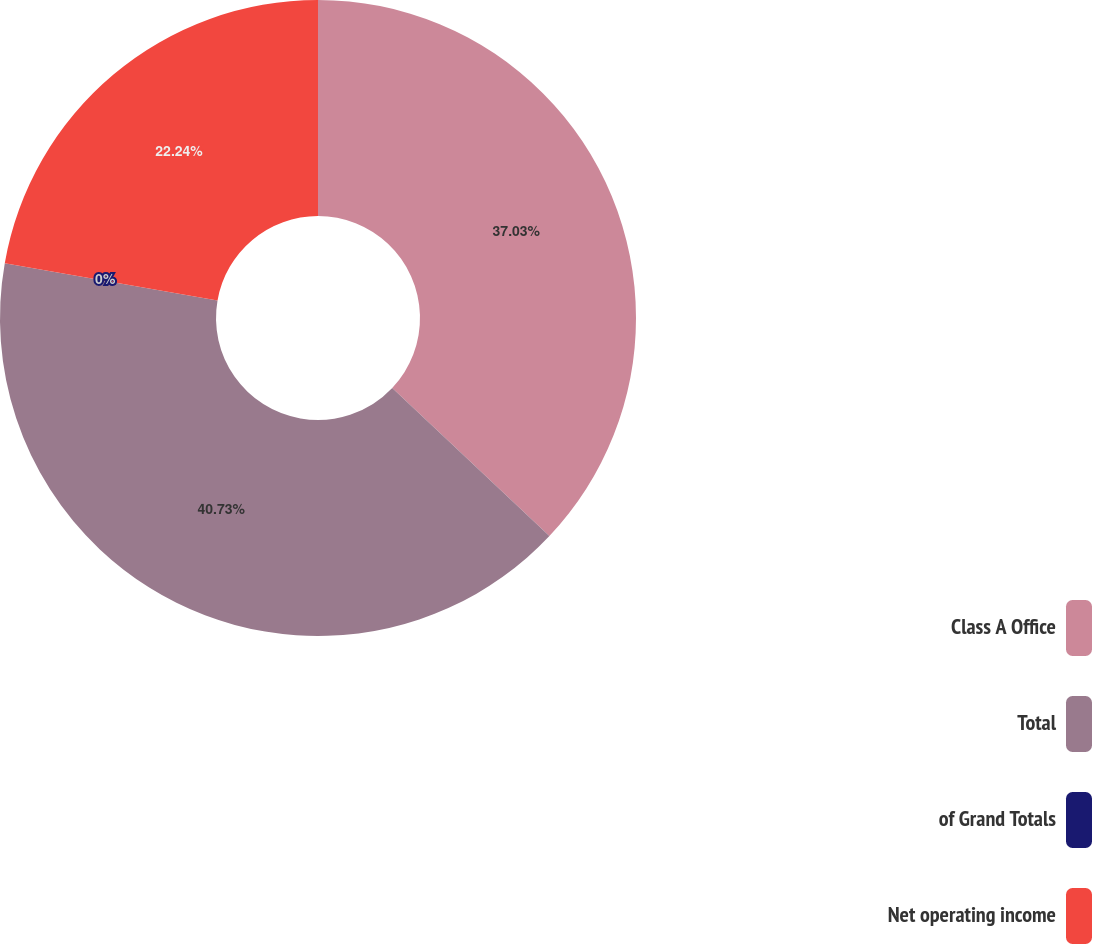Convert chart. <chart><loc_0><loc_0><loc_500><loc_500><pie_chart><fcel>Class A Office<fcel>Total<fcel>of Grand Totals<fcel>Net operating income<nl><fcel>37.03%<fcel>40.73%<fcel>0.0%<fcel>22.24%<nl></chart> 